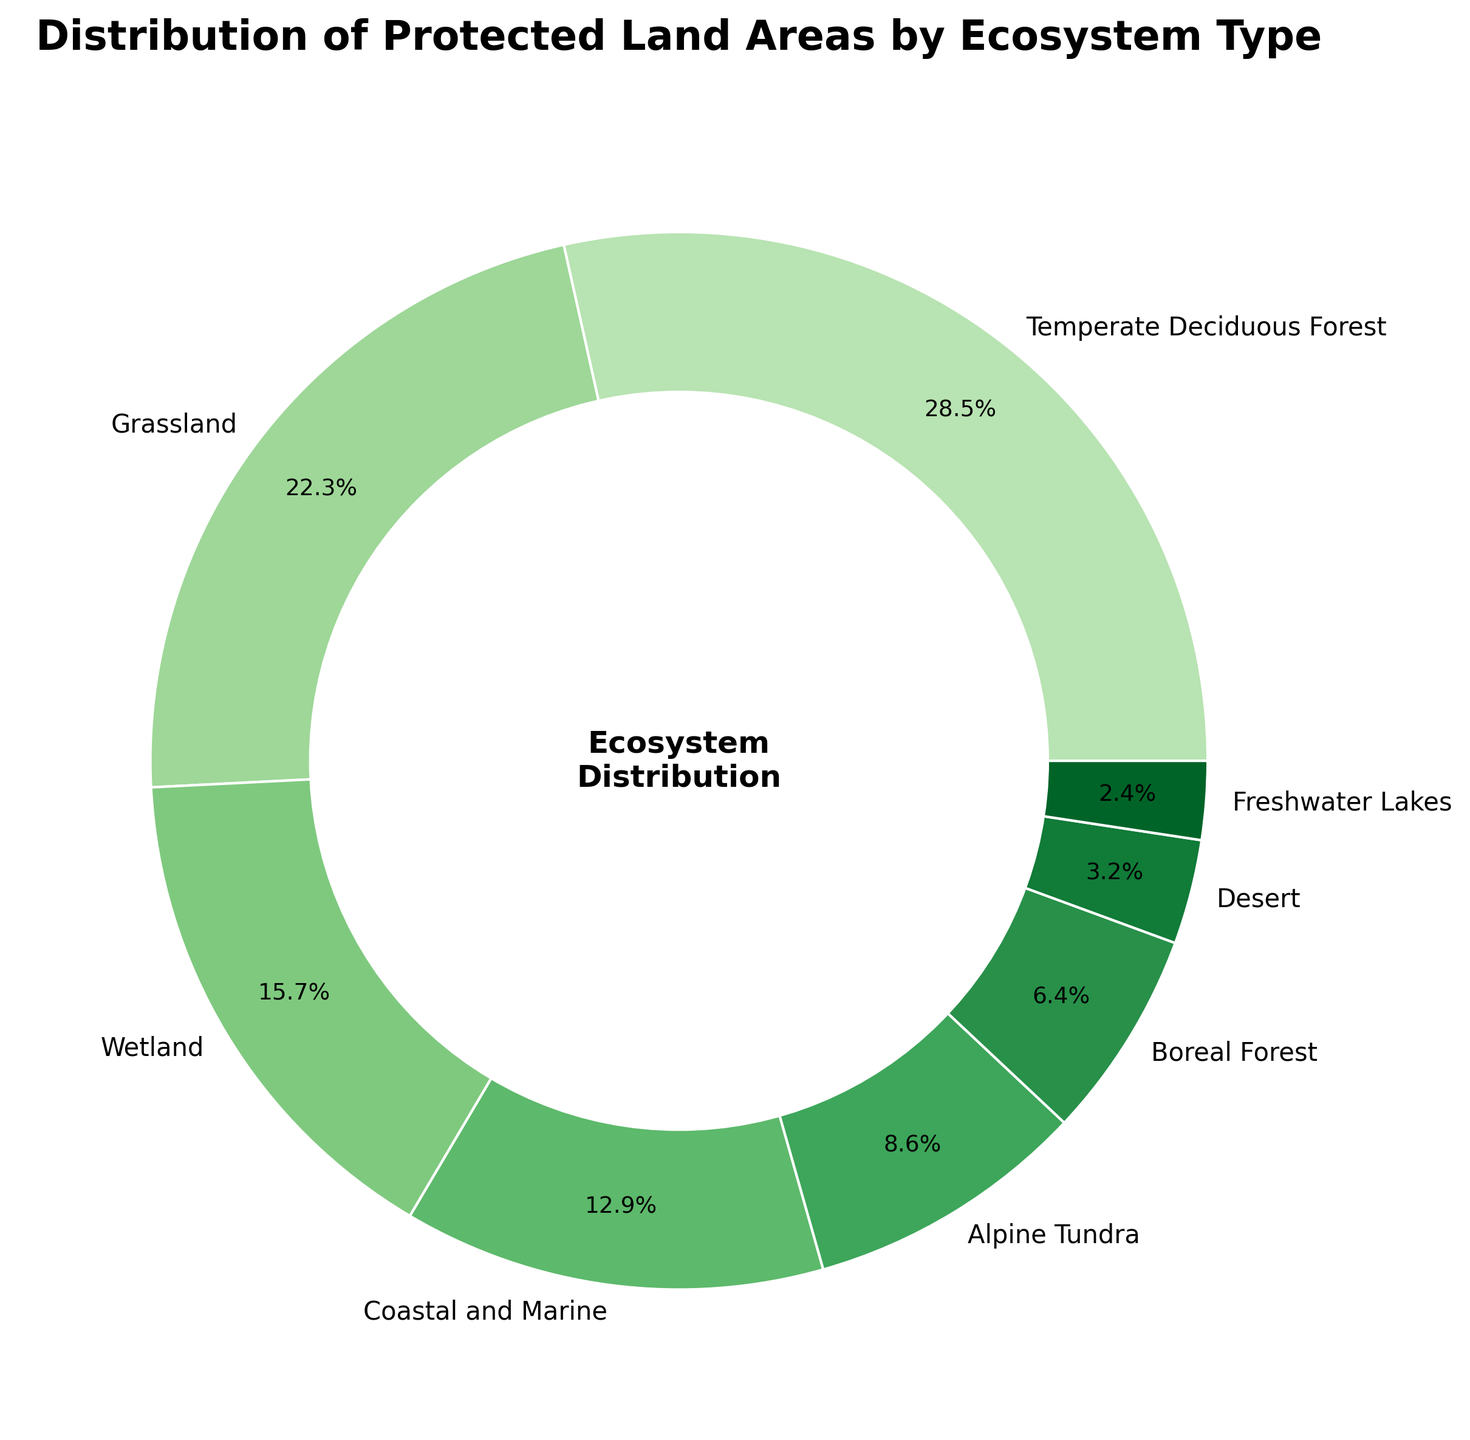What percentage of the protected land areas is covered by both Grassland and Wetland ecosystems combined? First, find the percentage values for Grassland and Wetland ecosystems from the figure, which are 22.3% and 15.7% respectively. Add these values together: 22.3% + 15.7% = 38.0%.
Answer: 38.0% Which ecosystem type has the smallest protected area? By referring to the figure, the ecosystem type with the smallest wedge is Freshwater Lakes with a percentage of 2.4%.
Answer: Freshwater Lakes Is the Boreal Forest protected area larger than the Alpine Tundra protected area? From the figure, Boreal Forest has 6.4% while Alpine Tundra has 8.6%. Since 6.4% is less than 8.6%, the Boreal Forest protected area is smaller.
Answer: No How much larger is the Temperate Deciduous Forest protected area compared to the Desert protected area? From the figure, the Temperate Deciduous Forest has 28.5% and the Desert has 3.2%. Subtract the Desert value from the Temperate Deciduous Forest value: 28.5% - 3.2% = 25.3%.
Answer: 25.3% Which ecosystem types have protected areas that are less than 10%? By referring to the figure, the ecosystem types with protected areas less than 10% are Alpine Tundra (8.6%), Boreal Forest (6.4%), Desert (3.2%), and Freshwater Lakes (2.4%).
Answer: Alpine Tundra, Boreal Forest, Desert, Freshwater Lakes What is the difference in the percentage of protected areas between Coastal and Marine and Grassland ecosystems? The Coastal and Marine and Grassland ecosystems have percentages of 12.9% and 22.3%, respectively. Subtract the smaller percentage from the larger one: 22.3% - 12.9% = 9.4%.
Answer: 9.4% Is the Grassland protected area more than double the Boreal Forest protected area? First, find the Grassland protected area (22.3%) and the Boreal Forest protected area (6.4%). Double the Boreal Forest value: 6.4% * 2 = 12.8%. Since 22.3% is greater than 12.8%, the Grassland protected area is more than double.
Answer: Yes What is the median percentage of the protected areas across all ecosystem types? Arrange the percentages in ascending order: 2.4%, 3.2%, 6.4%, 8.6%, 12.9%, 15.7%, 22.3%, 28.5%. Since there are 8 data points, the median will be the average of the 4th and 5th values: (8.6% + 12.9%) / 2 = 10.75%.
Answer: 10.75% What is the total percentage of protected areas for ecosystems other than Temperate Deciduous Forest and Grassland? The total percentage for Temperate Deciduous Forest and Grassland is 28.5% + 22.3% = 50.8%. Subtract this from 100%: 100% - 50.8% = 49.2%.
Answer: 49.2% 